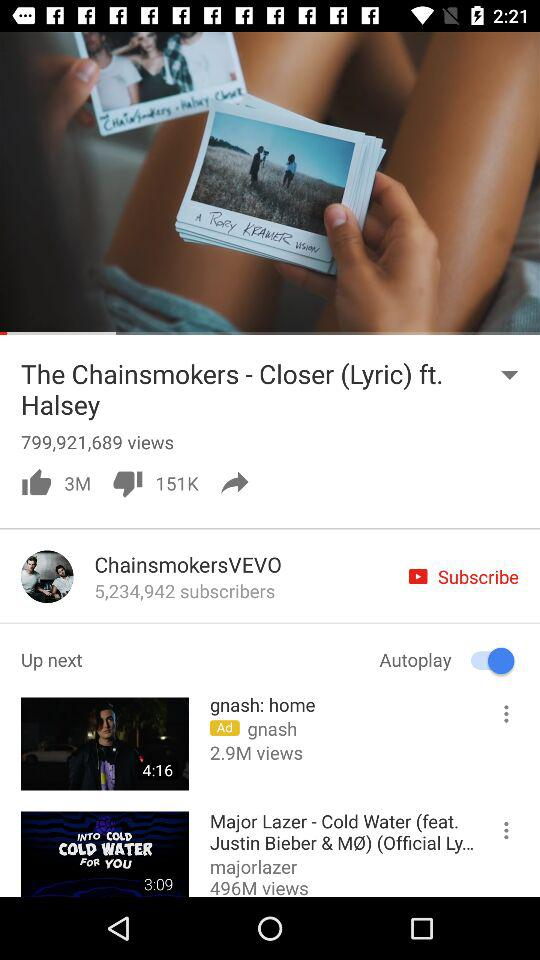How many people liked the song "Closer"? There are 3 million people. 